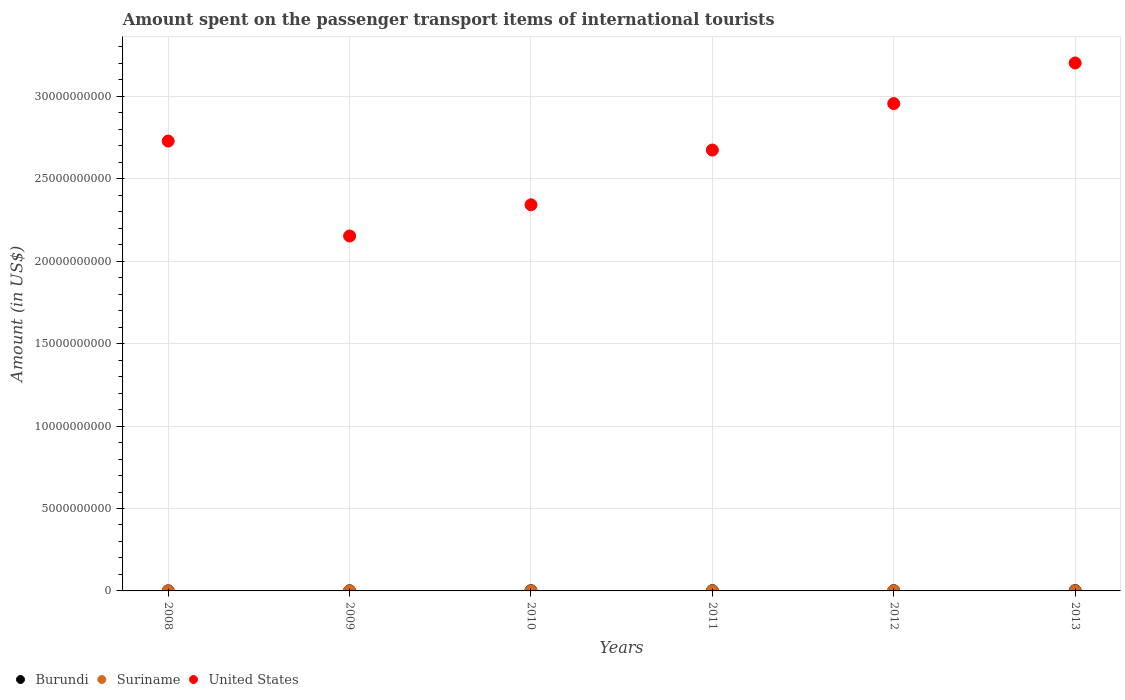What is the amount spent on the passenger transport items of international tourists in United States in 2013?
Provide a short and direct response. 3.20e+1. Across all years, what is the maximum amount spent on the passenger transport items of international tourists in Suriname?
Offer a terse response. 7.00e+06. Across all years, what is the minimum amount spent on the passenger transport items of international tourists in Suriname?
Your answer should be very brief. 2.00e+06. In which year was the amount spent on the passenger transport items of international tourists in United States maximum?
Provide a succinct answer. 2013. In which year was the amount spent on the passenger transport items of international tourists in Suriname minimum?
Provide a succinct answer. 2010. What is the total amount spent on the passenger transport items of international tourists in Suriname in the graph?
Provide a short and direct response. 2.90e+07. What is the difference between the amount spent on the passenger transport items of international tourists in Suriname in 2009 and that in 2012?
Ensure brevity in your answer.  -4.00e+06. What is the difference between the amount spent on the passenger transport items of international tourists in Burundi in 2008 and the amount spent on the passenger transport items of international tourists in United States in 2010?
Your answer should be compact. -2.34e+1. What is the average amount spent on the passenger transport items of international tourists in United States per year?
Provide a short and direct response. 2.68e+1. In the year 2013, what is the difference between the amount spent on the passenger transport items of international tourists in Suriname and amount spent on the passenger transport items of international tourists in United States?
Offer a terse response. -3.20e+1. What is the ratio of the amount spent on the passenger transport items of international tourists in Burundi in 2009 to that in 2013?
Keep it short and to the point. 0.45. Is the difference between the amount spent on the passenger transport items of international tourists in Suriname in 2012 and 2013 greater than the difference between the amount spent on the passenger transport items of international tourists in United States in 2012 and 2013?
Give a very brief answer. Yes. What is the difference between the highest and the second highest amount spent on the passenger transport items of international tourists in Burundi?
Your response must be concise. 2.00e+06. What is the difference between the highest and the lowest amount spent on the passenger transport items of international tourists in Suriname?
Your answer should be compact. 5.00e+06. In how many years, is the amount spent on the passenger transport items of international tourists in United States greater than the average amount spent on the passenger transport items of international tourists in United States taken over all years?
Give a very brief answer. 3. Does the amount spent on the passenger transport items of international tourists in Suriname monotonically increase over the years?
Provide a short and direct response. No. Is the amount spent on the passenger transport items of international tourists in Suriname strictly greater than the amount spent on the passenger transport items of international tourists in United States over the years?
Provide a succinct answer. No. How many dotlines are there?
Provide a succinct answer. 3. How many years are there in the graph?
Your answer should be compact. 6. Are the values on the major ticks of Y-axis written in scientific E-notation?
Your response must be concise. No. What is the title of the graph?
Your answer should be very brief. Amount spent on the passenger transport items of international tourists. What is the label or title of the X-axis?
Provide a succinct answer. Years. What is the label or title of the Y-axis?
Make the answer very short. Amount (in US$). What is the Amount (in US$) in Suriname in 2008?
Make the answer very short. 5.00e+06. What is the Amount (in US$) of United States in 2008?
Offer a very short reply. 2.73e+1. What is the Amount (in US$) of Burundi in 2009?
Provide a short and direct response. 9.00e+06. What is the Amount (in US$) in Suriname in 2009?
Make the answer very short. 3.00e+06. What is the Amount (in US$) in United States in 2009?
Your answer should be compact. 2.15e+1. What is the Amount (in US$) in Burundi in 2010?
Offer a very short reply. 1.50e+07. What is the Amount (in US$) of United States in 2010?
Give a very brief answer. 2.34e+1. What is the Amount (in US$) of Burundi in 2011?
Give a very brief answer. 1.80e+07. What is the Amount (in US$) of Suriname in 2011?
Your answer should be very brief. 7.00e+06. What is the Amount (in US$) of United States in 2011?
Your answer should be compact. 2.67e+1. What is the Amount (in US$) of Burundi in 2012?
Your answer should be very brief. 1.60e+07. What is the Amount (in US$) in Suriname in 2012?
Offer a very short reply. 7.00e+06. What is the Amount (in US$) of United States in 2012?
Ensure brevity in your answer.  2.96e+1. What is the Amount (in US$) in Burundi in 2013?
Offer a very short reply. 2.00e+07. What is the Amount (in US$) of United States in 2013?
Give a very brief answer. 3.20e+1. Across all years, what is the maximum Amount (in US$) of Burundi?
Offer a terse response. 2.00e+07. Across all years, what is the maximum Amount (in US$) in United States?
Provide a succinct answer. 3.20e+1. Across all years, what is the minimum Amount (in US$) in Burundi?
Your answer should be very brief. 7.00e+06. Across all years, what is the minimum Amount (in US$) in Suriname?
Provide a succinct answer. 2.00e+06. Across all years, what is the minimum Amount (in US$) in United States?
Give a very brief answer. 2.15e+1. What is the total Amount (in US$) in Burundi in the graph?
Make the answer very short. 8.50e+07. What is the total Amount (in US$) in Suriname in the graph?
Give a very brief answer. 2.90e+07. What is the total Amount (in US$) of United States in the graph?
Keep it short and to the point. 1.61e+11. What is the difference between the Amount (in US$) in Suriname in 2008 and that in 2009?
Your response must be concise. 2.00e+06. What is the difference between the Amount (in US$) of United States in 2008 and that in 2009?
Your answer should be compact. 5.76e+09. What is the difference between the Amount (in US$) of Burundi in 2008 and that in 2010?
Provide a succinct answer. -8.00e+06. What is the difference between the Amount (in US$) in United States in 2008 and that in 2010?
Provide a succinct answer. 3.87e+09. What is the difference between the Amount (in US$) in Burundi in 2008 and that in 2011?
Your answer should be very brief. -1.10e+07. What is the difference between the Amount (in US$) in United States in 2008 and that in 2011?
Your answer should be compact. 5.45e+08. What is the difference between the Amount (in US$) in Burundi in 2008 and that in 2012?
Keep it short and to the point. -9.00e+06. What is the difference between the Amount (in US$) of Suriname in 2008 and that in 2012?
Keep it short and to the point. -2.00e+06. What is the difference between the Amount (in US$) of United States in 2008 and that in 2012?
Provide a succinct answer. -2.27e+09. What is the difference between the Amount (in US$) of Burundi in 2008 and that in 2013?
Offer a very short reply. -1.30e+07. What is the difference between the Amount (in US$) of United States in 2008 and that in 2013?
Make the answer very short. -4.74e+09. What is the difference between the Amount (in US$) in Burundi in 2009 and that in 2010?
Your answer should be compact. -6.00e+06. What is the difference between the Amount (in US$) of Suriname in 2009 and that in 2010?
Your answer should be very brief. 1.00e+06. What is the difference between the Amount (in US$) of United States in 2009 and that in 2010?
Provide a short and direct response. -1.89e+09. What is the difference between the Amount (in US$) of Burundi in 2009 and that in 2011?
Your answer should be very brief. -9.00e+06. What is the difference between the Amount (in US$) of Suriname in 2009 and that in 2011?
Ensure brevity in your answer.  -4.00e+06. What is the difference between the Amount (in US$) in United States in 2009 and that in 2011?
Your answer should be very brief. -5.22e+09. What is the difference between the Amount (in US$) of Burundi in 2009 and that in 2012?
Offer a terse response. -7.00e+06. What is the difference between the Amount (in US$) of United States in 2009 and that in 2012?
Offer a very short reply. -8.03e+09. What is the difference between the Amount (in US$) of Burundi in 2009 and that in 2013?
Offer a terse response. -1.10e+07. What is the difference between the Amount (in US$) in Suriname in 2009 and that in 2013?
Keep it short and to the point. -2.00e+06. What is the difference between the Amount (in US$) of United States in 2009 and that in 2013?
Give a very brief answer. -1.05e+1. What is the difference between the Amount (in US$) of Suriname in 2010 and that in 2011?
Give a very brief answer. -5.00e+06. What is the difference between the Amount (in US$) in United States in 2010 and that in 2011?
Make the answer very short. -3.32e+09. What is the difference between the Amount (in US$) in Suriname in 2010 and that in 2012?
Offer a terse response. -5.00e+06. What is the difference between the Amount (in US$) of United States in 2010 and that in 2012?
Your answer should be very brief. -6.14e+09. What is the difference between the Amount (in US$) of Burundi in 2010 and that in 2013?
Provide a short and direct response. -5.00e+06. What is the difference between the Amount (in US$) in United States in 2010 and that in 2013?
Make the answer very short. -8.60e+09. What is the difference between the Amount (in US$) in United States in 2011 and that in 2012?
Your response must be concise. -2.82e+09. What is the difference between the Amount (in US$) of United States in 2011 and that in 2013?
Offer a very short reply. -5.28e+09. What is the difference between the Amount (in US$) of Suriname in 2012 and that in 2013?
Offer a very short reply. 2.00e+06. What is the difference between the Amount (in US$) in United States in 2012 and that in 2013?
Provide a succinct answer. -2.46e+09. What is the difference between the Amount (in US$) in Burundi in 2008 and the Amount (in US$) in United States in 2009?
Your answer should be very brief. -2.15e+1. What is the difference between the Amount (in US$) of Suriname in 2008 and the Amount (in US$) of United States in 2009?
Your response must be concise. -2.15e+1. What is the difference between the Amount (in US$) of Burundi in 2008 and the Amount (in US$) of Suriname in 2010?
Give a very brief answer. 5.00e+06. What is the difference between the Amount (in US$) of Burundi in 2008 and the Amount (in US$) of United States in 2010?
Keep it short and to the point. -2.34e+1. What is the difference between the Amount (in US$) of Suriname in 2008 and the Amount (in US$) of United States in 2010?
Give a very brief answer. -2.34e+1. What is the difference between the Amount (in US$) of Burundi in 2008 and the Amount (in US$) of United States in 2011?
Offer a very short reply. -2.67e+1. What is the difference between the Amount (in US$) of Suriname in 2008 and the Amount (in US$) of United States in 2011?
Provide a succinct answer. -2.67e+1. What is the difference between the Amount (in US$) of Burundi in 2008 and the Amount (in US$) of United States in 2012?
Provide a succinct answer. -2.96e+1. What is the difference between the Amount (in US$) of Suriname in 2008 and the Amount (in US$) of United States in 2012?
Provide a short and direct response. -2.96e+1. What is the difference between the Amount (in US$) of Burundi in 2008 and the Amount (in US$) of United States in 2013?
Provide a short and direct response. -3.20e+1. What is the difference between the Amount (in US$) of Suriname in 2008 and the Amount (in US$) of United States in 2013?
Offer a terse response. -3.20e+1. What is the difference between the Amount (in US$) of Burundi in 2009 and the Amount (in US$) of Suriname in 2010?
Your answer should be very brief. 7.00e+06. What is the difference between the Amount (in US$) of Burundi in 2009 and the Amount (in US$) of United States in 2010?
Offer a terse response. -2.34e+1. What is the difference between the Amount (in US$) in Suriname in 2009 and the Amount (in US$) in United States in 2010?
Your response must be concise. -2.34e+1. What is the difference between the Amount (in US$) of Burundi in 2009 and the Amount (in US$) of Suriname in 2011?
Offer a very short reply. 2.00e+06. What is the difference between the Amount (in US$) of Burundi in 2009 and the Amount (in US$) of United States in 2011?
Offer a terse response. -2.67e+1. What is the difference between the Amount (in US$) of Suriname in 2009 and the Amount (in US$) of United States in 2011?
Provide a succinct answer. -2.67e+1. What is the difference between the Amount (in US$) of Burundi in 2009 and the Amount (in US$) of United States in 2012?
Provide a short and direct response. -2.96e+1. What is the difference between the Amount (in US$) in Suriname in 2009 and the Amount (in US$) in United States in 2012?
Keep it short and to the point. -2.96e+1. What is the difference between the Amount (in US$) in Burundi in 2009 and the Amount (in US$) in United States in 2013?
Provide a short and direct response. -3.20e+1. What is the difference between the Amount (in US$) of Suriname in 2009 and the Amount (in US$) of United States in 2013?
Offer a terse response. -3.20e+1. What is the difference between the Amount (in US$) of Burundi in 2010 and the Amount (in US$) of United States in 2011?
Provide a succinct answer. -2.67e+1. What is the difference between the Amount (in US$) in Suriname in 2010 and the Amount (in US$) in United States in 2011?
Keep it short and to the point. -2.67e+1. What is the difference between the Amount (in US$) in Burundi in 2010 and the Amount (in US$) in Suriname in 2012?
Ensure brevity in your answer.  8.00e+06. What is the difference between the Amount (in US$) in Burundi in 2010 and the Amount (in US$) in United States in 2012?
Your answer should be compact. -2.96e+1. What is the difference between the Amount (in US$) in Suriname in 2010 and the Amount (in US$) in United States in 2012?
Your answer should be compact. -2.96e+1. What is the difference between the Amount (in US$) in Burundi in 2010 and the Amount (in US$) in United States in 2013?
Provide a short and direct response. -3.20e+1. What is the difference between the Amount (in US$) in Suriname in 2010 and the Amount (in US$) in United States in 2013?
Offer a terse response. -3.20e+1. What is the difference between the Amount (in US$) in Burundi in 2011 and the Amount (in US$) in Suriname in 2012?
Provide a succinct answer. 1.10e+07. What is the difference between the Amount (in US$) of Burundi in 2011 and the Amount (in US$) of United States in 2012?
Provide a short and direct response. -2.95e+1. What is the difference between the Amount (in US$) of Suriname in 2011 and the Amount (in US$) of United States in 2012?
Keep it short and to the point. -2.96e+1. What is the difference between the Amount (in US$) in Burundi in 2011 and the Amount (in US$) in Suriname in 2013?
Provide a short and direct response. 1.30e+07. What is the difference between the Amount (in US$) of Burundi in 2011 and the Amount (in US$) of United States in 2013?
Your response must be concise. -3.20e+1. What is the difference between the Amount (in US$) in Suriname in 2011 and the Amount (in US$) in United States in 2013?
Offer a terse response. -3.20e+1. What is the difference between the Amount (in US$) in Burundi in 2012 and the Amount (in US$) in Suriname in 2013?
Offer a very short reply. 1.10e+07. What is the difference between the Amount (in US$) in Burundi in 2012 and the Amount (in US$) in United States in 2013?
Provide a short and direct response. -3.20e+1. What is the difference between the Amount (in US$) of Suriname in 2012 and the Amount (in US$) of United States in 2013?
Keep it short and to the point. -3.20e+1. What is the average Amount (in US$) of Burundi per year?
Give a very brief answer. 1.42e+07. What is the average Amount (in US$) in Suriname per year?
Keep it short and to the point. 4.83e+06. What is the average Amount (in US$) in United States per year?
Offer a terse response. 2.68e+1. In the year 2008, what is the difference between the Amount (in US$) in Burundi and Amount (in US$) in United States?
Make the answer very short. -2.73e+1. In the year 2008, what is the difference between the Amount (in US$) in Suriname and Amount (in US$) in United States?
Make the answer very short. -2.73e+1. In the year 2009, what is the difference between the Amount (in US$) of Burundi and Amount (in US$) of United States?
Keep it short and to the point. -2.15e+1. In the year 2009, what is the difference between the Amount (in US$) of Suriname and Amount (in US$) of United States?
Provide a short and direct response. -2.15e+1. In the year 2010, what is the difference between the Amount (in US$) of Burundi and Amount (in US$) of Suriname?
Your answer should be compact. 1.30e+07. In the year 2010, what is the difference between the Amount (in US$) in Burundi and Amount (in US$) in United States?
Provide a short and direct response. -2.34e+1. In the year 2010, what is the difference between the Amount (in US$) in Suriname and Amount (in US$) in United States?
Your response must be concise. -2.34e+1. In the year 2011, what is the difference between the Amount (in US$) in Burundi and Amount (in US$) in Suriname?
Make the answer very short. 1.10e+07. In the year 2011, what is the difference between the Amount (in US$) in Burundi and Amount (in US$) in United States?
Offer a terse response. -2.67e+1. In the year 2011, what is the difference between the Amount (in US$) in Suriname and Amount (in US$) in United States?
Your answer should be very brief. -2.67e+1. In the year 2012, what is the difference between the Amount (in US$) of Burundi and Amount (in US$) of Suriname?
Keep it short and to the point. 9.00e+06. In the year 2012, what is the difference between the Amount (in US$) of Burundi and Amount (in US$) of United States?
Make the answer very short. -2.95e+1. In the year 2012, what is the difference between the Amount (in US$) in Suriname and Amount (in US$) in United States?
Your answer should be very brief. -2.96e+1. In the year 2013, what is the difference between the Amount (in US$) in Burundi and Amount (in US$) in Suriname?
Make the answer very short. 1.50e+07. In the year 2013, what is the difference between the Amount (in US$) of Burundi and Amount (in US$) of United States?
Your answer should be very brief. -3.20e+1. In the year 2013, what is the difference between the Amount (in US$) in Suriname and Amount (in US$) in United States?
Keep it short and to the point. -3.20e+1. What is the ratio of the Amount (in US$) in Suriname in 2008 to that in 2009?
Keep it short and to the point. 1.67. What is the ratio of the Amount (in US$) in United States in 2008 to that in 2009?
Your answer should be compact. 1.27. What is the ratio of the Amount (in US$) of Burundi in 2008 to that in 2010?
Your answer should be very brief. 0.47. What is the ratio of the Amount (in US$) in Suriname in 2008 to that in 2010?
Provide a short and direct response. 2.5. What is the ratio of the Amount (in US$) in United States in 2008 to that in 2010?
Provide a short and direct response. 1.17. What is the ratio of the Amount (in US$) in Burundi in 2008 to that in 2011?
Make the answer very short. 0.39. What is the ratio of the Amount (in US$) of United States in 2008 to that in 2011?
Provide a succinct answer. 1.02. What is the ratio of the Amount (in US$) of Burundi in 2008 to that in 2012?
Offer a terse response. 0.44. What is the ratio of the Amount (in US$) of United States in 2008 to that in 2012?
Offer a terse response. 0.92. What is the ratio of the Amount (in US$) in Burundi in 2008 to that in 2013?
Ensure brevity in your answer.  0.35. What is the ratio of the Amount (in US$) of United States in 2008 to that in 2013?
Your answer should be compact. 0.85. What is the ratio of the Amount (in US$) of Burundi in 2009 to that in 2010?
Offer a terse response. 0.6. What is the ratio of the Amount (in US$) in Suriname in 2009 to that in 2010?
Give a very brief answer. 1.5. What is the ratio of the Amount (in US$) of United States in 2009 to that in 2010?
Offer a terse response. 0.92. What is the ratio of the Amount (in US$) of Burundi in 2009 to that in 2011?
Offer a very short reply. 0.5. What is the ratio of the Amount (in US$) in Suriname in 2009 to that in 2011?
Offer a terse response. 0.43. What is the ratio of the Amount (in US$) in United States in 2009 to that in 2011?
Your response must be concise. 0.81. What is the ratio of the Amount (in US$) of Burundi in 2009 to that in 2012?
Keep it short and to the point. 0.56. What is the ratio of the Amount (in US$) of Suriname in 2009 to that in 2012?
Provide a succinct answer. 0.43. What is the ratio of the Amount (in US$) of United States in 2009 to that in 2012?
Your answer should be very brief. 0.73. What is the ratio of the Amount (in US$) in Burundi in 2009 to that in 2013?
Your response must be concise. 0.45. What is the ratio of the Amount (in US$) in Suriname in 2009 to that in 2013?
Your response must be concise. 0.6. What is the ratio of the Amount (in US$) of United States in 2009 to that in 2013?
Your answer should be very brief. 0.67. What is the ratio of the Amount (in US$) in Suriname in 2010 to that in 2011?
Your response must be concise. 0.29. What is the ratio of the Amount (in US$) of United States in 2010 to that in 2011?
Offer a terse response. 0.88. What is the ratio of the Amount (in US$) of Burundi in 2010 to that in 2012?
Keep it short and to the point. 0.94. What is the ratio of the Amount (in US$) of Suriname in 2010 to that in 2012?
Offer a terse response. 0.29. What is the ratio of the Amount (in US$) of United States in 2010 to that in 2012?
Your answer should be compact. 0.79. What is the ratio of the Amount (in US$) of Suriname in 2010 to that in 2013?
Make the answer very short. 0.4. What is the ratio of the Amount (in US$) of United States in 2010 to that in 2013?
Keep it short and to the point. 0.73. What is the ratio of the Amount (in US$) of Burundi in 2011 to that in 2012?
Make the answer very short. 1.12. What is the ratio of the Amount (in US$) in United States in 2011 to that in 2012?
Provide a succinct answer. 0.9. What is the ratio of the Amount (in US$) in United States in 2011 to that in 2013?
Provide a succinct answer. 0.84. What is the ratio of the Amount (in US$) of Burundi in 2012 to that in 2013?
Provide a succinct answer. 0.8. What is the difference between the highest and the second highest Amount (in US$) of Burundi?
Give a very brief answer. 2.00e+06. What is the difference between the highest and the second highest Amount (in US$) of United States?
Your answer should be compact. 2.46e+09. What is the difference between the highest and the lowest Amount (in US$) of Burundi?
Ensure brevity in your answer.  1.30e+07. What is the difference between the highest and the lowest Amount (in US$) of United States?
Your response must be concise. 1.05e+1. 